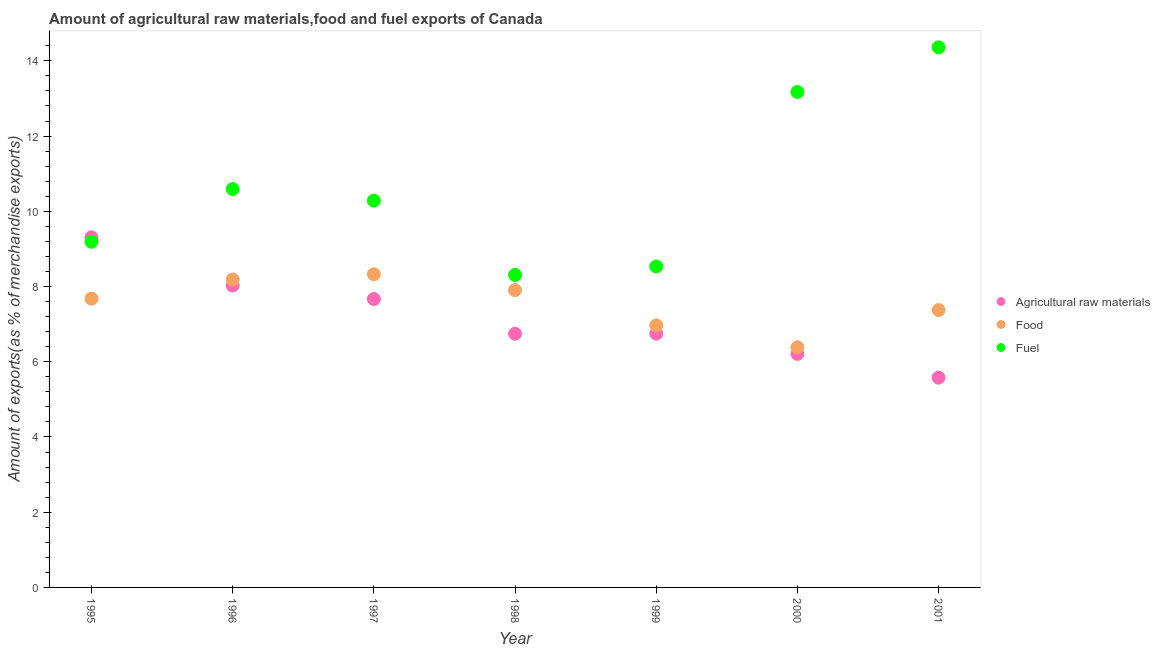How many different coloured dotlines are there?
Ensure brevity in your answer.  3. Is the number of dotlines equal to the number of legend labels?
Give a very brief answer. Yes. What is the percentage of fuel exports in 1999?
Give a very brief answer. 8.53. Across all years, what is the maximum percentage of fuel exports?
Provide a short and direct response. 14.36. Across all years, what is the minimum percentage of fuel exports?
Offer a very short reply. 8.31. What is the total percentage of raw materials exports in the graph?
Your answer should be compact. 50.28. What is the difference between the percentage of fuel exports in 1998 and that in 1999?
Provide a short and direct response. -0.23. What is the difference between the percentage of raw materials exports in 1997 and the percentage of food exports in 2001?
Make the answer very short. 0.29. What is the average percentage of raw materials exports per year?
Offer a very short reply. 7.18. In the year 1996, what is the difference between the percentage of food exports and percentage of fuel exports?
Your response must be concise. -2.41. In how many years, is the percentage of raw materials exports greater than 0.8 %?
Your answer should be compact. 7. What is the ratio of the percentage of raw materials exports in 1995 to that in 2000?
Your answer should be very brief. 1.5. Is the difference between the percentage of raw materials exports in 1996 and 2000 greater than the difference between the percentage of fuel exports in 1996 and 2000?
Your response must be concise. Yes. What is the difference between the highest and the second highest percentage of fuel exports?
Offer a very short reply. 1.19. What is the difference between the highest and the lowest percentage of raw materials exports?
Ensure brevity in your answer.  3.73. In how many years, is the percentage of raw materials exports greater than the average percentage of raw materials exports taken over all years?
Your answer should be compact. 3. Is it the case that in every year, the sum of the percentage of raw materials exports and percentage of food exports is greater than the percentage of fuel exports?
Offer a terse response. No. Does the percentage of raw materials exports monotonically increase over the years?
Make the answer very short. No. Is the percentage of fuel exports strictly greater than the percentage of raw materials exports over the years?
Offer a terse response. No. Is the percentage of fuel exports strictly less than the percentage of raw materials exports over the years?
Your answer should be very brief. No. How many dotlines are there?
Your response must be concise. 3. How many years are there in the graph?
Ensure brevity in your answer.  7. What is the difference between two consecutive major ticks on the Y-axis?
Your answer should be very brief. 2. Are the values on the major ticks of Y-axis written in scientific E-notation?
Give a very brief answer. No. Does the graph contain any zero values?
Your response must be concise. No. Where does the legend appear in the graph?
Your answer should be very brief. Center right. What is the title of the graph?
Provide a succinct answer. Amount of agricultural raw materials,food and fuel exports of Canada. What is the label or title of the Y-axis?
Give a very brief answer. Amount of exports(as % of merchandise exports). What is the Amount of exports(as % of merchandise exports) of Agricultural raw materials in 1995?
Your answer should be compact. 9.31. What is the Amount of exports(as % of merchandise exports) in Food in 1995?
Your answer should be very brief. 7.68. What is the Amount of exports(as % of merchandise exports) in Fuel in 1995?
Your answer should be very brief. 9.19. What is the Amount of exports(as % of merchandise exports) of Agricultural raw materials in 1996?
Offer a very short reply. 8.03. What is the Amount of exports(as % of merchandise exports) of Food in 1996?
Provide a succinct answer. 8.19. What is the Amount of exports(as % of merchandise exports) in Fuel in 1996?
Ensure brevity in your answer.  10.59. What is the Amount of exports(as % of merchandise exports) of Agricultural raw materials in 1997?
Keep it short and to the point. 7.67. What is the Amount of exports(as % of merchandise exports) in Food in 1997?
Provide a succinct answer. 8.33. What is the Amount of exports(as % of merchandise exports) of Fuel in 1997?
Make the answer very short. 10.28. What is the Amount of exports(as % of merchandise exports) of Agricultural raw materials in 1998?
Your answer should be very brief. 6.75. What is the Amount of exports(as % of merchandise exports) in Food in 1998?
Give a very brief answer. 7.9. What is the Amount of exports(as % of merchandise exports) in Fuel in 1998?
Ensure brevity in your answer.  8.31. What is the Amount of exports(as % of merchandise exports) of Agricultural raw materials in 1999?
Offer a very short reply. 6.75. What is the Amount of exports(as % of merchandise exports) in Food in 1999?
Ensure brevity in your answer.  6.97. What is the Amount of exports(as % of merchandise exports) of Fuel in 1999?
Make the answer very short. 8.53. What is the Amount of exports(as % of merchandise exports) in Agricultural raw materials in 2000?
Make the answer very short. 6.21. What is the Amount of exports(as % of merchandise exports) in Food in 2000?
Give a very brief answer. 6.38. What is the Amount of exports(as % of merchandise exports) in Fuel in 2000?
Give a very brief answer. 13.17. What is the Amount of exports(as % of merchandise exports) of Agricultural raw materials in 2001?
Ensure brevity in your answer.  5.58. What is the Amount of exports(as % of merchandise exports) of Food in 2001?
Offer a terse response. 7.37. What is the Amount of exports(as % of merchandise exports) in Fuel in 2001?
Your response must be concise. 14.36. Across all years, what is the maximum Amount of exports(as % of merchandise exports) of Agricultural raw materials?
Ensure brevity in your answer.  9.31. Across all years, what is the maximum Amount of exports(as % of merchandise exports) in Food?
Make the answer very short. 8.33. Across all years, what is the maximum Amount of exports(as % of merchandise exports) in Fuel?
Make the answer very short. 14.36. Across all years, what is the minimum Amount of exports(as % of merchandise exports) in Agricultural raw materials?
Offer a very short reply. 5.58. Across all years, what is the minimum Amount of exports(as % of merchandise exports) in Food?
Your answer should be very brief. 6.38. Across all years, what is the minimum Amount of exports(as % of merchandise exports) in Fuel?
Provide a short and direct response. 8.31. What is the total Amount of exports(as % of merchandise exports) in Agricultural raw materials in the graph?
Provide a succinct answer. 50.28. What is the total Amount of exports(as % of merchandise exports) in Food in the graph?
Your response must be concise. 52.82. What is the total Amount of exports(as % of merchandise exports) in Fuel in the graph?
Ensure brevity in your answer.  74.44. What is the difference between the Amount of exports(as % of merchandise exports) in Agricultural raw materials in 1995 and that in 1996?
Provide a succinct answer. 1.28. What is the difference between the Amount of exports(as % of merchandise exports) of Food in 1995 and that in 1996?
Make the answer very short. -0.51. What is the difference between the Amount of exports(as % of merchandise exports) in Fuel in 1995 and that in 1996?
Provide a succinct answer. -1.4. What is the difference between the Amount of exports(as % of merchandise exports) of Agricultural raw materials in 1995 and that in 1997?
Give a very brief answer. 1.64. What is the difference between the Amount of exports(as % of merchandise exports) of Food in 1995 and that in 1997?
Offer a terse response. -0.65. What is the difference between the Amount of exports(as % of merchandise exports) in Fuel in 1995 and that in 1997?
Make the answer very short. -1.09. What is the difference between the Amount of exports(as % of merchandise exports) in Agricultural raw materials in 1995 and that in 1998?
Offer a terse response. 2.56. What is the difference between the Amount of exports(as % of merchandise exports) in Food in 1995 and that in 1998?
Offer a terse response. -0.23. What is the difference between the Amount of exports(as % of merchandise exports) in Fuel in 1995 and that in 1998?
Provide a succinct answer. 0.88. What is the difference between the Amount of exports(as % of merchandise exports) of Agricultural raw materials in 1995 and that in 1999?
Provide a short and direct response. 2.56. What is the difference between the Amount of exports(as % of merchandise exports) in Food in 1995 and that in 1999?
Your answer should be compact. 0.71. What is the difference between the Amount of exports(as % of merchandise exports) in Fuel in 1995 and that in 1999?
Offer a terse response. 0.66. What is the difference between the Amount of exports(as % of merchandise exports) of Agricultural raw materials in 1995 and that in 2000?
Ensure brevity in your answer.  3.1. What is the difference between the Amount of exports(as % of merchandise exports) of Food in 1995 and that in 2000?
Offer a terse response. 1.29. What is the difference between the Amount of exports(as % of merchandise exports) in Fuel in 1995 and that in 2000?
Make the answer very short. -3.98. What is the difference between the Amount of exports(as % of merchandise exports) of Agricultural raw materials in 1995 and that in 2001?
Your response must be concise. 3.73. What is the difference between the Amount of exports(as % of merchandise exports) of Food in 1995 and that in 2001?
Your response must be concise. 0.3. What is the difference between the Amount of exports(as % of merchandise exports) in Fuel in 1995 and that in 2001?
Your answer should be compact. -5.17. What is the difference between the Amount of exports(as % of merchandise exports) in Agricultural raw materials in 1996 and that in 1997?
Give a very brief answer. 0.36. What is the difference between the Amount of exports(as % of merchandise exports) of Food in 1996 and that in 1997?
Make the answer very short. -0.14. What is the difference between the Amount of exports(as % of merchandise exports) of Fuel in 1996 and that in 1997?
Provide a short and direct response. 0.31. What is the difference between the Amount of exports(as % of merchandise exports) in Agricultural raw materials in 1996 and that in 1998?
Provide a short and direct response. 1.28. What is the difference between the Amount of exports(as % of merchandise exports) in Food in 1996 and that in 1998?
Offer a very short reply. 0.28. What is the difference between the Amount of exports(as % of merchandise exports) in Fuel in 1996 and that in 1998?
Provide a succinct answer. 2.28. What is the difference between the Amount of exports(as % of merchandise exports) in Agricultural raw materials in 1996 and that in 1999?
Offer a terse response. 1.28. What is the difference between the Amount of exports(as % of merchandise exports) in Food in 1996 and that in 1999?
Your answer should be compact. 1.22. What is the difference between the Amount of exports(as % of merchandise exports) of Fuel in 1996 and that in 1999?
Provide a short and direct response. 2.06. What is the difference between the Amount of exports(as % of merchandise exports) of Agricultural raw materials in 1996 and that in 2000?
Offer a terse response. 1.82. What is the difference between the Amount of exports(as % of merchandise exports) of Food in 1996 and that in 2000?
Make the answer very short. 1.8. What is the difference between the Amount of exports(as % of merchandise exports) in Fuel in 1996 and that in 2000?
Offer a very short reply. -2.58. What is the difference between the Amount of exports(as % of merchandise exports) in Agricultural raw materials in 1996 and that in 2001?
Ensure brevity in your answer.  2.45. What is the difference between the Amount of exports(as % of merchandise exports) of Food in 1996 and that in 2001?
Provide a succinct answer. 0.81. What is the difference between the Amount of exports(as % of merchandise exports) of Fuel in 1996 and that in 2001?
Offer a terse response. -3.77. What is the difference between the Amount of exports(as % of merchandise exports) of Agricultural raw materials in 1997 and that in 1998?
Provide a succinct answer. 0.92. What is the difference between the Amount of exports(as % of merchandise exports) of Food in 1997 and that in 1998?
Make the answer very short. 0.42. What is the difference between the Amount of exports(as % of merchandise exports) of Fuel in 1997 and that in 1998?
Your answer should be compact. 1.97. What is the difference between the Amount of exports(as % of merchandise exports) in Agricultural raw materials in 1997 and that in 1999?
Ensure brevity in your answer.  0.92. What is the difference between the Amount of exports(as % of merchandise exports) of Food in 1997 and that in 1999?
Your response must be concise. 1.36. What is the difference between the Amount of exports(as % of merchandise exports) in Fuel in 1997 and that in 1999?
Ensure brevity in your answer.  1.75. What is the difference between the Amount of exports(as % of merchandise exports) of Agricultural raw materials in 1997 and that in 2000?
Ensure brevity in your answer.  1.46. What is the difference between the Amount of exports(as % of merchandise exports) of Food in 1997 and that in 2000?
Make the answer very short. 1.94. What is the difference between the Amount of exports(as % of merchandise exports) in Fuel in 1997 and that in 2000?
Provide a succinct answer. -2.89. What is the difference between the Amount of exports(as % of merchandise exports) in Agricultural raw materials in 1997 and that in 2001?
Your response must be concise. 2.09. What is the difference between the Amount of exports(as % of merchandise exports) in Food in 1997 and that in 2001?
Your response must be concise. 0.95. What is the difference between the Amount of exports(as % of merchandise exports) in Fuel in 1997 and that in 2001?
Provide a short and direct response. -4.08. What is the difference between the Amount of exports(as % of merchandise exports) of Agricultural raw materials in 1998 and that in 1999?
Offer a very short reply. -0. What is the difference between the Amount of exports(as % of merchandise exports) of Food in 1998 and that in 1999?
Provide a short and direct response. 0.94. What is the difference between the Amount of exports(as % of merchandise exports) in Fuel in 1998 and that in 1999?
Your answer should be very brief. -0.23. What is the difference between the Amount of exports(as % of merchandise exports) of Agricultural raw materials in 1998 and that in 2000?
Keep it short and to the point. 0.54. What is the difference between the Amount of exports(as % of merchandise exports) of Food in 1998 and that in 2000?
Make the answer very short. 1.52. What is the difference between the Amount of exports(as % of merchandise exports) of Fuel in 1998 and that in 2000?
Keep it short and to the point. -4.87. What is the difference between the Amount of exports(as % of merchandise exports) in Agricultural raw materials in 1998 and that in 2001?
Make the answer very short. 1.17. What is the difference between the Amount of exports(as % of merchandise exports) of Food in 1998 and that in 2001?
Give a very brief answer. 0.53. What is the difference between the Amount of exports(as % of merchandise exports) of Fuel in 1998 and that in 2001?
Offer a terse response. -6.05. What is the difference between the Amount of exports(as % of merchandise exports) in Agricultural raw materials in 1999 and that in 2000?
Provide a succinct answer. 0.54. What is the difference between the Amount of exports(as % of merchandise exports) of Food in 1999 and that in 2000?
Ensure brevity in your answer.  0.58. What is the difference between the Amount of exports(as % of merchandise exports) of Fuel in 1999 and that in 2000?
Make the answer very short. -4.64. What is the difference between the Amount of exports(as % of merchandise exports) in Agricultural raw materials in 1999 and that in 2001?
Provide a succinct answer. 1.17. What is the difference between the Amount of exports(as % of merchandise exports) of Food in 1999 and that in 2001?
Your answer should be very brief. -0.41. What is the difference between the Amount of exports(as % of merchandise exports) in Fuel in 1999 and that in 2001?
Keep it short and to the point. -5.82. What is the difference between the Amount of exports(as % of merchandise exports) in Agricultural raw materials in 2000 and that in 2001?
Your answer should be compact. 0.63. What is the difference between the Amount of exports(as % of merchandise exports) in Food in 2000 and that in 2001?
Provide a short and direct response. -0.99. What is the difference between the Amount of exports(as % of merchandise exports) in Fuel in 2000 and that in 2001?
Your answer should be compact. -1.19. What is the difference between the Amount of exports(as % of merchandise exports) in Agricultural raw materials in 1995 and the Amount of exports(as % of merchandise exports) in Food in 1996?
Make the answer very short. 1.12. What is the difference between the Amount of exports(as % of merchandise exports) of Agricultural raw materials in 1995 and the Amount of exports(as % of merchandise exports) of Fuel in 1996?
Provide a succinct answer. -1.28. What is the difference between the Amount of exports(as % of merchandise exports) in Food in 1995 and the Amount of exports(as % of merchandise exports) in Fuel in 1996?
Ensure brevity in your answer.  -2.91. What is the difference between the Amount of exports(as % of merchandise exports) in Agricultural raw materials in 1995 and the Amount of exports(as % of merchandise exports) in Food in 1997?
Keep it short and to the point. 0.98. What is the difference between the Amount of exports(as % of merchandise exports) in Agricultural raw materials in 1995 and the Amount of exports(as % of merchandise exports) in Fuel in 1997?
Ensure brevity in your answer.  -0.97. What is the difference between the Amount of exports(as % of merchandise exports) in Food in 1995 and the Amount of exports(as % of merchandise exports) in Fuel in 1997?
Make the answer very short. -2.61. What is the difference between the Amount of exports(as % of merchandise exports) in Agricultural raw materials in 1995 and the Amount of exports(as % of merchandise exports) in Food in 1998?
Offer a terse response. 1.41. What is the difference between the Amount of exports(as % of merchandise exports) of Agricultural raw materials in 1995 and the Amount of exports(as % of merchandise exports) of Fuel in 1998?
Make the answer very short. 1. What is the difference between the Amount of exports(as % of merchandise exports) in Food in 1995 and the Amount of exports(as % of merchandise exports) in Fuel in 1998?
Give a very brief answer. -0.63. What is the difference between the Amount of exports(as % of merchandise exports) in Agricultural raw materials in 1995 and the Amount of exports(as % of merchandise exports) in Food in 1999?
Offer a terse response. 2.34. What is the difference between the Amount of exports(as % of merchandise exports) of Agricultural raw materials in 1995 and the Amount of exports(as % of merchandise exports) of Fuel in 1999?
Make the answer very short. 0.78. What is the difference between the Amount of exports(as % of merchandise exports) of Food in 1995 and the Amount of exports(as % of merchandise exports) of Fuel in 1999?
Ensure brevity in your answer.  -0.86. What is the difference between the Amount of exports(as % of merchandise exports) in Agricultural raw materials in 1995 and the Amount of exports(as % of merchandise exports) in Food in 2000?
Provide a succinct answer. 2.92. What is the difference between the Amount of exports(as % of merchandise exports) of Agricultural raw materials in 1995 and the Amount of exports(as % of merchandise exports) of Fuel in 2000?
Provide a short and direct response. -3.86. What is the difference between the Amount of exports(as % of merchandise exports) of Food in 1995 and the Amount of exports(as % of merchandise exports) of Fuel in 2000?
Provide a succinct answer. -5.5. What is the difference between the Amount of exports(as % of merchandise exports) in Agricultural raw materials in 1995 and the Amount of exports(as % of merchandise exports) in Food in 2001?
Give a very brief answer. 1.93. What is the difference between the Amount of exports(as % of merchandise exports) of Agricultural raw materials in 1995 and the Amount of exports(as % of merchandise exports) of Fuel in 2001?
Ensure brevity in your answer.  -5.05. What is the difference between the Amount of exports(as % of merchandise exports) in Food in 1995 and the Amount of exports(as % of merchandise exports) in Fuel in 2001?
Provide a succinct answer. -6.68. What is the difference between the Amount of exports(as % of merchandise exports) in Agricultural raw materials in 1996 and the Amount of exports(as % of merchandise exports) in Food in 1997?
Ensure brevity in your answer.  -0.3. What is the difference between the Amount of exports(as % of merchandise exports) in Agricultural raw materials in 1996 and the Amount of exports(as % of merchandise exports) in Fuel in 1997?
Keep it short and to the point. -2.26. What is the difference between the Amount of exports(as % of merchandise exports) of Food in 1996 and the Amount of exports(as % of merchandise exports) of Fuel in 1997?
Your response must be concise. -2.1. What is the difference between the Amount of exports(as % of merchandise exports) in Agricultural raw materials in 1996 and the Amount of exports(as % of merchandise exports) in Food in 1998?
Ensure brevity in your answer.  0.12. What is the difference between the Amount of exports(as % of merchandise exports) in Agricultural raw materials in 1996 and the Amount of exports(as % of merchandise exports) in Fuel in 1998?
Give a very brief answer. -0.28. What is the difference between the Amount of exports(as % of merchandise exports) in Food in 1996 and the Amount of exports(as % of merchandise exports) in Fuel in 1998?
Your answer should be compact. -0.12. What is the difference between the Amount of exports(as % of merchandise exports) in Agricultural raw materials in 1996 and the Amount of exports(as % of merchandise exports) in Food in 1999?
Your answer should be compact. 1.06. What is the difference between the Amount of exports(as % of merchandise exports) of Agricultural raw materials in 1996 and the Amount of exports(as % of merchandise exports) of Fuel in 1999?
Provide a succinct answer. -0.51. What is the difference between the Amount of exports(as % of merchandise exports) in Food in 1996 and the Amount of exports(as % of merchandise exports) in Fuel in 1999?
Ensure brevity in your answer.  -0.35. What is the difference between the Amount of exports(as % of merchandise exports) in Agricultural raw materials in 1996 and the Amount of exports(as % of merchandise exports) in Food in 2000?
Keep it short and to the point. 1.64. What is the difference between the Amount of exports(as % of merchandise exports) of Agricultural raw materials in 1996 and the Amount of exports(as % of merchandise exports) of Fuel in 2000?
Offer a terse response. -5.15. What is the difference between the Amount of exports(as % of merchandise exports) in Food in 1996 and the Amount of exports(as % of merchandise exports) in Fuel in 2000?
Give a very brief answer. -4.99. What is the difference between the Amount of exports(as % of merchandise exports) of Agricultural raw materials in 1996 and the Amount of exports(as % of merchandise exports) of Food in 2001?
Provide a succinct answer. 0.65. What is the difference between the Amount of exports(as % of merchandise exports) of Agricultural raw materials in 1996 and the Amount of exports(as % of merchandise exports) of Fuel in 2001?
Your response must be concise. -6.33. What is the difference between the Amount of exports(as % of merchandise exports) in Food in 1996 and the Amount of exports(as % of merchandise exports) in Fuel in 2001?
Provide a succinct answer. -6.17. What is the difference between the Amount of exports(as % of merchandise exports) in Agricultural raw materials in 1997 and the Amount of exports(as % of merchandise exports) in Food in 1998?
Your answer should be very brief. -0.24. What is the difference between the Amount of exports(as % of merchandise exports) of Agricultural raw materials in 1997 and the Amount of exports(as % of merchandise exports) of Fuel in 1998?
Offer a terse response. -0.64. What is the difference between the Amount of exports(as % of merchandise exports) of Food in 1997 and the Amount of exports(as % of merchandise exports) of Fuel in 1998?
Make the answer very short. 0.02. What is the difference between the Amount of exports(as % of merchandise exports) in Agricultural raw materials in 1997 and the Amount of exports(as % of merchandise exports) in Food in 1999?
Your response must be concise. 0.7. What is the difference between the Amount of exports(as % of merchandise exports) in Agricultural raw materials in 1997 and the Amount of exports(as % of merchandise exports) in Fuel in 1999?
Your answer should be very brief. -0.87. What is the difference between the Amount of exports(as % of merchandise exports) of Food in 1997 and the Amount of exports(as % of merchandise exports) of Fuel in 1999?
Offer a terse response. -0.21. What is the difference between the Amount of exports(as % of merchandise exports) of Agricultural raw materials in 1997 and the Amount of exports(as % of merchandise exports) of Food in 2000?
Your answer should be compact. 1.28. What is the difference between the Amount of exports(as % of merchandise exports) of Agricultural raw materials in 1997 and the Amount of exports(as % of merchandise exports) of Fuel in 2000?
Offer a terse response. -5.51. What is the difference between the Amount of exports(as % of merchandise exports) in Food in 1997 and the Amount of exports(as % of merchandise exports) in Fuel in 2000?
Provide a short and direct response. -4.85. What is the difference between the Amount of exports(as % of merchandise exports) in Agricultural raw materials in 1997 and the Amount of exports(as % of merchandise exports) in Food in 2001?
Provide a short and direct response. 0.29. What is the difference between the Amount of exports(as % of merchandise exports) in Agricultural raw materials in 1997 and the Amount of exports(as % of merchandise exports) in Fuel in 2001?
Ensure brevity in your answer.  -6.69. What is the difference between the Amount of exports(as % of merchandise exports) in Food in 1997 and the Amount of exports(as % of merchandise exports) in Fuel in 2001?
Your answer should be compact. -6.03. What is the difference between the Amount of exports(as % of merchandise exports) of Agricultural raw materials in 1998 and the Amount of exports(as % of merchandise exports) of Food in 1999?
Ensure brevity in your answer.  -0.22. What is the difference between the Amount of exports(as % of merchandise exports) in Agricultural raw materials in 1998 and the Amount of exports(as % of merchandise exports) in Fuel in 1999?
Your response must be concise. -1.79. What is the difference between the Amount of exports(as % of merchandise exports) of Food in 1998 and the Amount of exports(as % of merchandise exports) of Fuel in 1999?
Offer a terse response. -0.63. What is the difference between the Amount of exports(as % of merchandise exports) in Agricultural raw materials in 1998 and the Amount of exports(as % of merchandise exports) in Food in 2000?
Keep it short and to the point. 0.36. What is the difference between the Amount of exports(as % of merchandise exports) in Agricultural raw materials in 1998 and the Amount of exports(as % of merchandise exports) in Fuel in 2000?
Ensure brevity in your answer.  -6.43. What is the difference between the Amount of exports(as % of merchandise exports) in Food in 1998 and the Amount of exports(as % of merchandise exports) in Fuel in 2000?
Keep it short and to the point. -5.27. What is the difference between the Amount of exports(as % of merchandise exports) of Agricultural raw materials in 1998 and the Amount of exports(as % of merchandise exports) of Food in 2001?
Keep it short and to the point. -0.63. What is the difference between the Amount of exports(as % of merchandise exports) in Agricultural raw materials in 1998 and the Amount of exports(as % of merchandise exports) in Fuel in 2001?
Make the answer very short. -7.61. What is the difference between the Amount of exports(as % of merchandise exports) in Food in 1998 and the Amount of exports(as % of merchandise exports) in Fuel in 2001?
Offer a terse response. -6.46. What is the difference between the Amount of exports(as % of merchandise exports) of Agricultural raw materials in 1999 and the Amount of exports(as % of merchandise exports) of Food in 2000?
Ensure brevity in your answer.  0.36. What is the difference between the Amount of exports(as % of merchandise exports) in Agricultural raw materials in 1999 and the Amount of exports(as % of merchandise exports) in Fuel in 2000?
Provide a short and direct response. -6.43. What is the difference between the Amount of exports(as % of merchandise exports) of Food in 1999 and the Amount of exports(as % of merchandise exports) of Fuel in 2000?
Offer a very short reply. -6.21. What is the difference between the Amount of exports(as % of merchandise exports) of Agricultural raw materials in 1999 and the Amount of exports(as % of merchandise exports) of Food in 2001?
Make the answer very short. -0.63. What is the difference between the Amount of exports(as % of merchandise exports) in Agricultural raw materials in 1999 and the Amount of exports(as % of merchandise exports) in Fuel in 2001?
Ensure brevity in your answer.  -7.61. What is the difference between the Amount of exports(as % of merchandise exports) in Food in 1999 and the Amount of exports(as % of merchandise exports) in Fuel in 2001?
Your response must be concise. -7.39. What is the difference between the Amount of exports(as % of merchandise exports) of Agricultural raw materials in 2000 and the Amount of exports(as % of merchandise exports) of Food in 2001?
Your answer should be very brief. -1.16. What is the difference between the Amount of exports(as % of merchandise exports) of Agricultural raw materials in 2000 and the Amount of exports(as % of merchandise exports) of Fuel in 2001?
Offer a very short reply. -8.15. What is the difference between the Amount of exports(as % of merchandise exports) of Food in 2000 and the Amount of exports(as % of merchandise exports) of Fuel in 2001?
Your response must be concise. -7.97. What is the average Amount of exports(as % of merchandise exports) in Agricultural raw materials per year?
Offer a terse response. 7.18. What is the average Amount of exports(as % of merchandise exports) of Food per year?
Make the answer very short. 7.55. What is the average Amount of exports(as % of merchandise exports) in Fuel per year?
Ensure brevity in your answer.  10.63. In the year 1995, what is the difference between the Amount of exports(as % of merchandise exports) in Agricultural raw materials and Amount of exports(as % of merchandise exports) in Food?
Offer a terse response. 1.63. In the year 1995, what is the difference between the Amount of exports(as % of merchandise exports) in Agricultural raw materials and Amount of exports(as % of merchandise exports) in Fuel?
Make the answer very short. 0.12. In the year 1995, what is the difference between the Amount of exports(as % of merchandise exports) of Food and Amount of exports(as % of merchandise exports) of Fuel?
Ensure brevity in your answer.  -1.51. In the year 1996, what is the difference between the Amount of exports(as % of merchandise exports) of Agricultural raw materials and Amount of exports(as % of merchandise exports) of Food?
Make the answer very short. -0.16. In the year 1996, what is the difference between the Amount of exports(as % of merchandise exports) in Agricultural raw materials and Amount of exports(as % of merchandise exports) in Fuel?
Keep it short and to the point. -2.56. In the year 1996, what is the difference between the Amount of exports(as % of merchandise exports) of Food and Amount of exports(as % of merchandise exports) of Fuel?
Keep it short and to the point. -2.41. In the year 1997, what is the difference between the Amount of exports(as % of merchandise exports) in Agricultural raw materials and Amount of exports(as % of merchandise exports) in Food?
Your answer should be very brief. -0.66. In the year 1997, what is the difference between the Amount of exports(as % of merchandise exports) in Agricultural raw materials and Amount of exports(as % of merchandise exports) in Fuel?
Provide a short and direct response. -2.62. In the year 1997, what is the difference between the Amount of exports(as % of merchandise exports) in Food and Amount of exports(as % of merchandise exports) in Fuel?
Offer a terse response. -1.96. In the year 1998, what is the difference between the Amount of exports(as % of merchandise exports) of Agricultural raw materials and Amount of exports(as % of merchandise exports) of Food?
Your answer should be very brief. -1.16. In the year 1998, what is the difference between the Amount of exports(as % of merchandise exports) of Agricultural raw materials and Amount of exports(as % of merchandise exports) of Fuel?
Ensure brevity in your answer.  -1.56. In the year 1998, what is the difference between the Amount of exports(as % of merchandise exports) in Food and Amount of exports(as % of merchandise exports) in Fuel?
Make the answer very short. -0.4. In the year 1999, what is the difference between the Amount of exports(as % of merchandise exports) of Agricultural raw materials and Amount of exports(as % of merchandise exports) of Food?
Provide a short and direct response. -0.22. In the year 1999, what is the difference between the Amount of exports(as % of merchandise exports) of Agricultural raw materials and Amount of exports(as % of merchandise exports) of Fuel?
Provide a succinct answer. -1.79. In the year 1999, what is the difference between the Amount of exports(as % of merchandise exports) of Food and Amount of exports(as % of merchandise exports) of Fuel?
Give a very brief answer. -1.57. In the year 2000, what is the difference between the Amount of exports(as % of merchandise exports) in Agricultural raw materials and Amount of exports(as % of merchandise exports) in Food?
Your response must be concise. -0.17. In the year 2000, what is the difference between the Amount of exports(as % of merchandise exports) of Agricultural raw materials and Amount of exports(as % of merchandise exports) of Fuel?
Provide a short and direct response. -6.96. In the year 2000, what is the difference between the Amount of exports(as % of merchandise exports) of Food and Amount of exports(as % of merchandise exports) of Fuel?
Offer a terse response. -6.79. In the year 2001, what is the difference between the Amount of exports(as % of merchandise exports) in Agricultural raw materials and Amount of exports(as % of merchandise exports) in Food?
Your response must be concise. -1.8. In the year 2001, what is the difference between the Amount of exports(as % of merchandise exports) of Agricultural raw materials and Amount of exports(as % of merchandise exports) of Fuel?
Make the answer very short. -8.78. In the year 2001, what is the difference between the Amount of exports(as % of merchandise exports) in Food and Amount of exports(as % of merchandise exports) in Fuel?
Your answer should be very brief. -6.98. What is the ratio of the Amount of exports(as % of merchandise exports) of Agricultural raw materials in 1995 to that in 1996?
Your answer should be very brief. 1.16. What is the ratio of the Amount of exports(as % of merchandise exports) of Food in 1995 to that in 1996?
Ensure brevity in your answer.  0.94. What is the ratio of the Amount of exports(as % of merchandise exports) of Fuel in 1995 to that in 1996?
Keep it short and to the point. 0.87. What is the ratio of the Amount of exports(as % of merchandise exports) in Agricultural raw materials in 1995 to that in 1997?
Give a very brief answer. 1.21. What is the ratio of the Amount of exports(as % of merchandise exports) of Food in 1995 to that in 1997?
Your answer should be very brief. 0.92. What is the ratio of the Amount of exports(as % of merchandise exports) in Fuel in 1995 to that in 1997?
Offer a very short reply. 0.89. What is the ratio of the Amount of exports(as % of merchandise exports) of Agricultural raw materials in 1995 to that in 1998?
Your answer should be compact. 1.38. What is the ratio of the Amount of exports(as % of merchandise exports) in Food in 1995 to that in 1998?
Offer a terse response. 0.97. What is the ratio of the Amount of exports(as % of merchandise exports) in Fuel in 1995 to that in 1998?
Your answer should be compact. 1.11. What is the ratio of the Amount of exports(as % of merchandise exports) in Agricultural raw materials in 1995 to that in 1999?
Your answer should be very brief. 1.38. What is the ratio of the Amount of exports(as % of merchandise exports) in Food in 1995 to that in 1999?
Offer a terse response. 1.1. What is the ratio of the Amount of exports(as % of merchandise exports) of Fuel in 1995 to that in 1999?
Ensure brevity in your answer.  1.08. What is the ratio of the Amount of exports(as % of merchandise exports) of Agricultural raw materials in 1995 to that in 2000?
Keep it short and to the point. 1.5. What is the ratio of the Amount of exports(as % of merchandise exports) of Food in 1995 to that in 2000?
Your answer should be very brief. 1.2. What is the ratio of the Amount of exports(as % of merchandise exports) of Fuel in 1995 to that in 2000?
Keep it short and to the point. 0.7. What is the ratio of the Amount of exports(as % of merchandise exports) of Agricultural raw materials in 1995 to that in 2001?
Offer a terse response. 1.67. What is the ratio of the Amount of exports(as % of merchandise exports) of Food in 1995 to that in 2001?
Offer a very short reply. 1.04. What is the ratio of the Amount of exports(as % of merchandise exports) of Fuel in 1995 to that in 2001?
Keep it short and to the point. 0.64. What is the ratio of the Amount of exports(as % of merchandise exports) in Agricultural raw materials in 1996 to that in 1997?
Offer a very short reply. 1.05. What is the ratio of the Amount of exports(as % of merchandise exports) of Food in 1996 to that in 1997?
Your answer should be compact. 0.98. What is the ratio of the Amount of exports(as % of merchandise exports) in Fuel in 1996 to that in 1997?
Ensure brevity in your answer.  1.03. What is the ratio of the Amount of exports(as % of merchandise exports) of Agricultural raw materials in 1996 to that in 1998?
Make the answer very short. 1.19. What is the ratio of the Amount of exports(as % of merchandise exports) in Food in 1996 to that in 1998?
Your answer should be compact. 1.04. What is the ratio of the Amount of exports(as % of merchandise exports) in Fuel in 1996 to that in 1998?
Your response must be concise. 1.27. What is the ratio of the Amount of exports(as % of merchandise exports) of Agricultural raw materials in 1996 to that in 1999?
Your response must be concise. 1.19. What is the ratio of the Amount of exports(as % of merchandise exports) of Food in 1996 to that in 1999?
Offer a very short reply. 1.18. What is the ratio of the Amount of exports(as % of merchandise exports) of Fuel in 1996 to that in 1999?
Make the answer very short. 1.24. What is the ratio of the Amount of exports(as % of merchandise exports) of Agricultural raw materials in 1996 to that in 2000?
Give a very brief answer. 1.29. What is the ratio of the Amount of exports(as % of merchandise exports) of Food in 1996 to that in 2000?
Provide a succinct answer. 1.28. What is the ratio of the Amount of exports(as % of merchandise exports) in Fuel in 1996 to that in 2000?
Your answer should be very brief. 0.8. What is the ratio of the Amount of exports(as % of merchandise exports) of Agricultural raw materials in 1996 to that in 2001?
Keep it short and to the point. 1.44. What is the ratio of the Amount of exports(as % of merchandise exports) in Food in 1996 to that in 2001?
Give a very brief answer. 1.11. What is the ratio of the Amount of exports(as % of merchandise exports) in Fuel in 1996 to that in 2001?
Your answer should be compact. 0.74. What is the ratio of the Amount of exports(as % of merchandise exports) of Agricultural raw materials in 1997 to that in 1998?
Give a very brief answer. 1.14. What is the ratio of the Amount of exports(as % of merchandise exports) of Food in 1997 to that in 1998?
Provide a short and direct response. 1.05. What is the ratio of the Amount of exports(as % of merchandise exports) of Fuel in 1997 to that in 1998?
Ensure brevity in your answer.  1.24. What is the ratio of the Amount of exports(as % of merchandise exports) in Agricultural raw materials in 1997 to that in 1999?
Give a very brief answer. 1.14. What is the ratio of the Amount of exports(as % of merchandise exports) of Food in 1997 to that in 1999?
Your response must be concise. 1.2. What is the ratio of the Amount of exports(as % of merchandise exports) in Fuel in 1997 to that in 1999?
Make the answer very short. 1.2. What is the ratio of the Amount of exports(as % of merchandise exports) in Agricultural raw materials in 1997 to that in 2000?
Ensure brevity in your answer.  1.23. What is the ratio of the Amount of exports(as % of merchandise exports) in Food in 1997 to that in 2000?
Keep it short and to the point. 1.3. What is the ratio of the Amount of exports(as % of merchandise exports) in Fuel in 1997 to that in 2000?
Provide a succinct answer. 0.78. What is the ratio of the Amount of exports(as % of merchandise exports) in Agricultural raw materials in 1997 to that in 2001?
Provide a short and direct response. 1.37. What is the ratio of the Amount of exports(as % of merchandise exports) in Food in 1997 to that in 2001?
Offer a very short reply. 1.13. What is the ratio of the Amount of exports(as % of merchandise exports) in Fuel in 1997 to that in 2001?
Offer a terse response. 0.72. What is the ratio of the Amount of exports(as % of merchandise exports) of Food in 1998 to that in 1999?
Give a very brief answer. 1.13. What is the ratio of the Amount of exports(as % of merchandise exports) in Fuel in 1998 to that in 1999?
Ensure brevity in your answer.  0.97. What is the ratio of the Amount of exports(as % of merchandise exports) of Agricultural raw materials in 1998 to that in 2000?
Ensure brevity in your answer.  1.09. What is the ratio of the Amount of exports(as % of merchandise exports) of Food in 1998 to that in 2000?
Make the answer very short. 1.24. What is the ratio of the Amount of exports(as % of merchandise exports) in Fuel in 1998 to that in 2000?
Provide a succinct answer. 0.63. What is the ratio of the Amount of exports(as % of merchandise exports) in Agricultural raw materials in 1998 to that in 2001?
Offer a very short reply. 1.21. What is the ratio of the Amount of exports(as % of merchandise exports) of Food in 1998 to that in 2001?
Your answer should be very brief. 1.07. What is the ratio of the Amount of exports(as % of merchandise exports) of Fuel in 1998 to that in 2001?
Ensure brevity in your answer.  0.58. What is the ratio of the Amount of exports(as % of merchandise exports) of Agricultural raw materials in 1999 to that in 2000?
Offer a terse response. 1.09. What is the ratio of the Amount of exports(as % of merchandise exports) in Food in 1999 to that in 2000?
Offer a very short reply. 1.09. What is the ratio of the Amount of exports(as % of merchandise exports) of Fuel in 1999 to that in 2000?
Your answer should be compact. 0.65. What is the ratio of the Amount of exports(as % of merchandise exports) in Agricultural raw materials in 1999 to that in 2001?
Your answer should be very brief. 1.21. What is the ratio of the Amount of exports(as % of merchandise exports) in Food in 1999 to that in 2001?
Your answer should be compact. 0.94. What is the ratio of the Amount of exports(as % of merchandise exports) of Fuel in 1999 to that in 2001?
Ensure brevity in your answer.  0.59. What is the ratio of the Amount of exports(as % of merchandise exports) of Agricultural raw materials in 2000 to that in 2001?
Give a very brief answer. 1.11. What is the ratio of the Amount of exports(as % of merchandise exports) in Food in 2000 to that in 2001?
Your answer should be compact. 0.87. What is the ratio of the Amount of exports(as % of merchandise exports) of Fuel in 2000 to that in 2001?
Give a very brief answer. 0.92. What is the difference between the highest and the second highest Amount of exports(as % of merchandise exports) of Agricultural raw materials?
Ensure brevity in your answer.  1.28. What is the difference between the highest and the second highest Amount of exports(as % of merchandise exports) of Food?
Provide a short and direct response. 0.14. What is the difference between the highest and the second highest Amount of exports(as % of merchandise exports) in Fuel?
Ensure brevity in your answer.  1.19. What is the difference between the highest and the lowest Amount of exports(as % of merchandise exports) of Agricultural raw materials?
Provide a short and direct response. 3.73. What is the difference between the highest and the lowest Amount of exports(as % of merchandise exports) in Food?
Offer a very short reply. 1.94. What is the difference between the highest and the lowest Amount of exports(as % of merchandise exports) in Fuel?
Offer a terse response. 6.05. 